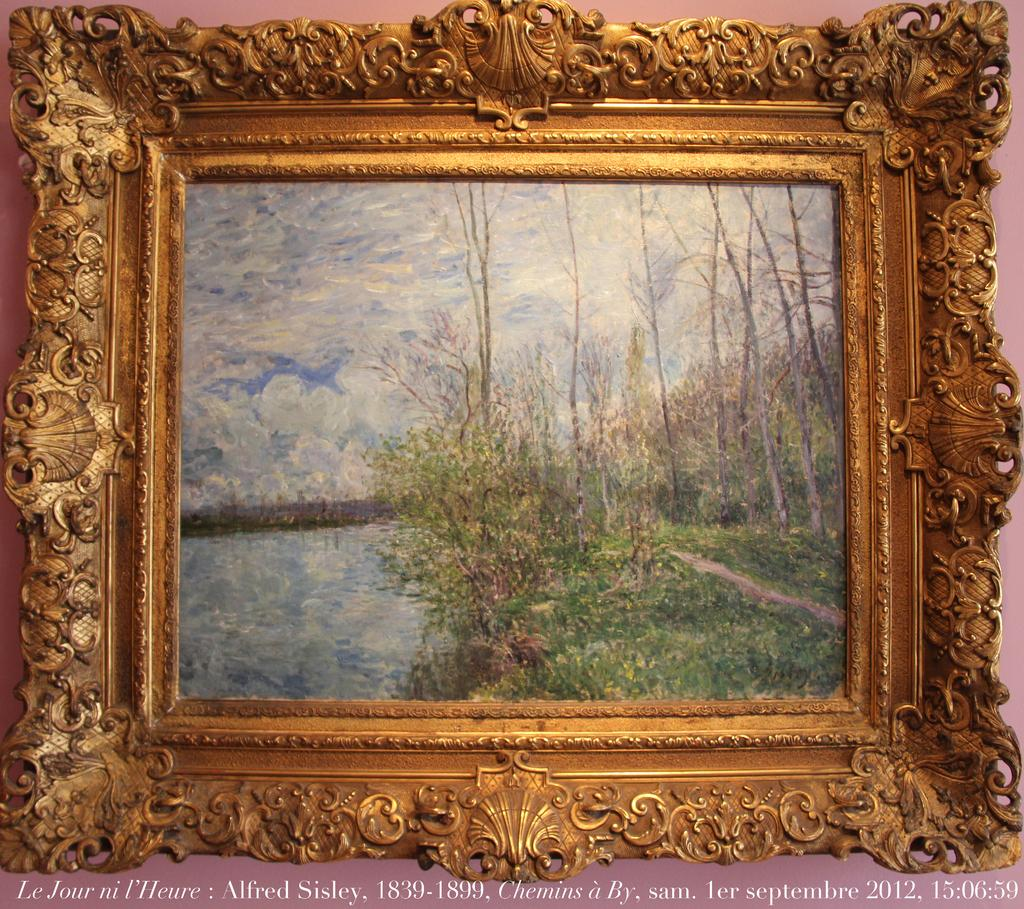What is the main subject of the image? There is a frame in the image. What can be seen within the frame? Trees, water, and the sky are visible within the frame. What is the color of the background in the image? The background of the image is pink. Is there any text present in the image? Yes, there is text at the bottom of the image. How many geese are swimming in the water within the frame? There are no geese visible within the frame; only trees, water, and the sky can be seen. What type of heart-shaped object is present in the image? There is no heart-shaped object present in the image. 